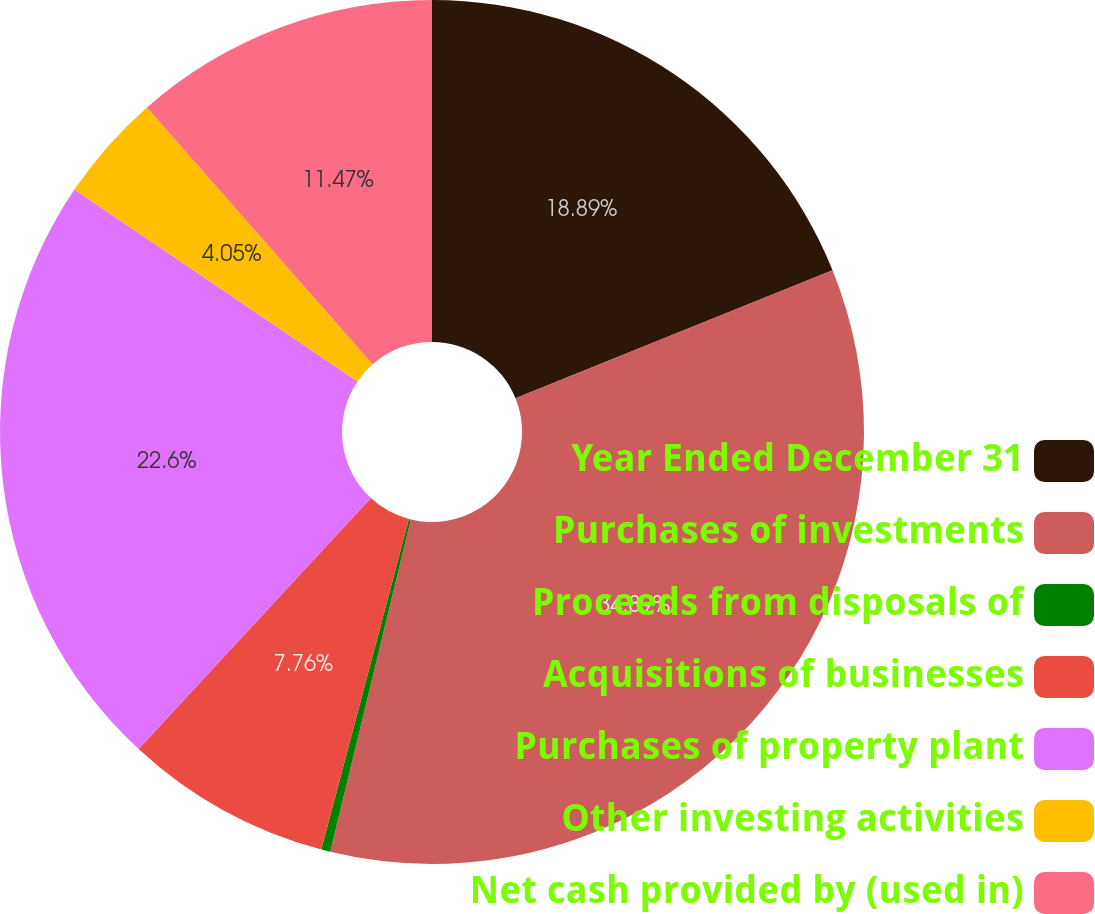<chart> <loc_0><loc_0><loc_500><loc_500><pie_chart><fcel>Year Ended December 31<fcel>Purchases of investments<fcel>Proceeds from disposals of<fcel>Acquisitions of businesses<fcel>Purchases of property plant<fcel>Other investing activities<fcel>Net cash provided by (used in)<nl><fcel>18.89%<fcel>34.9%<fcel>0.34%<fcel>7.76%<fcel>22.6%<fcel>4.05%<fcel>11.47%<nl></chart> 